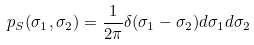Convert formula to latex. <formula><loc_0><loc_0><loc_500><loc_500>p _ { S } ( \sigma _ { 1 } , \sigma _ { 2 } ) = \frac { 1 } { 2 \pi } \delta ( \sigma _ { 1 } - \sigma _ { 2 } ) d \sigma _ { 1 } d \sigma _ { 2 }</formula> 